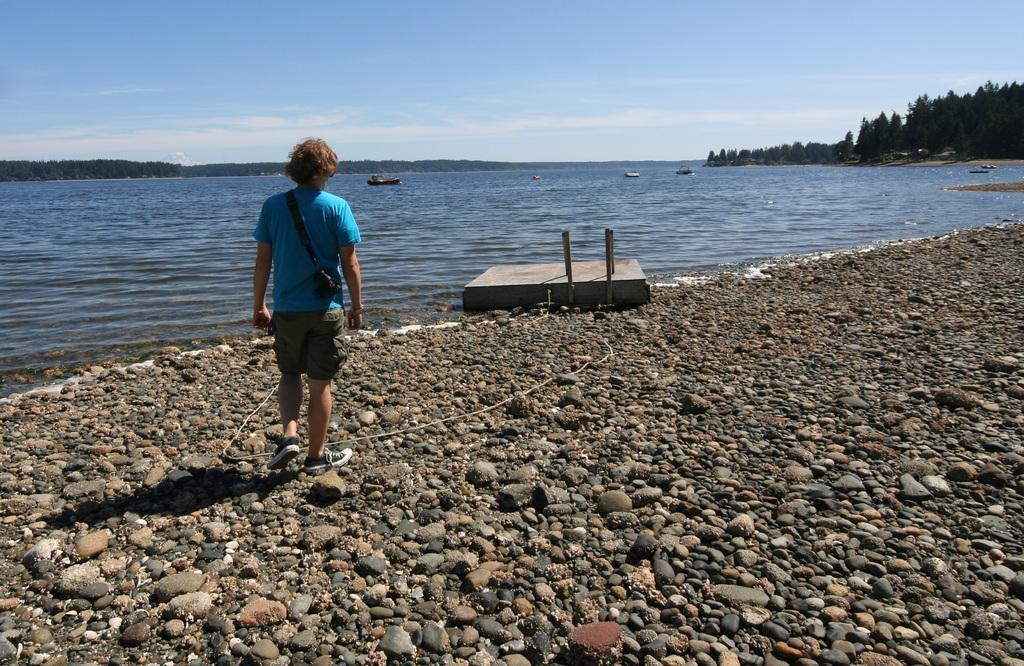Describe this image in one or two sentences. The man in blue T-shirt is standing at the sea shore. Beside him, we see water and this water might be in the sea. At the bottom of the picture, we see the stones. There are trees in the background. At the top of the picture, we see the sky. 